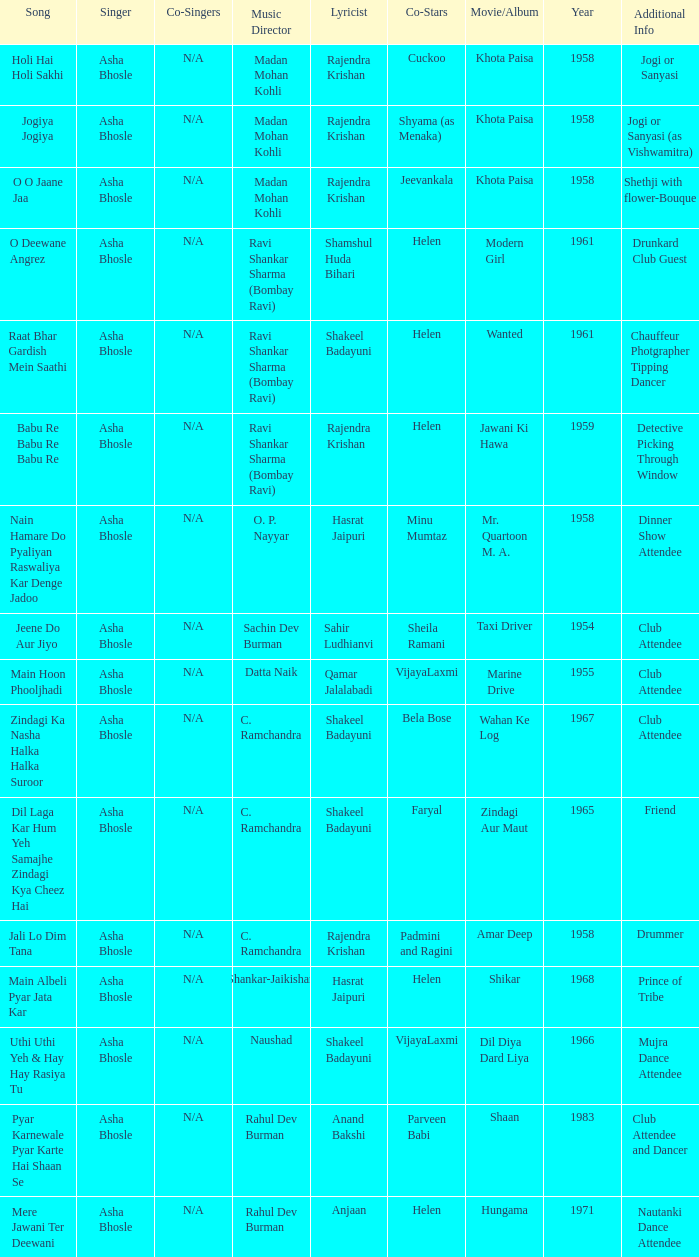Who wrote the lyrics when Jeevankala co-starred? Rajendra Krishan. 